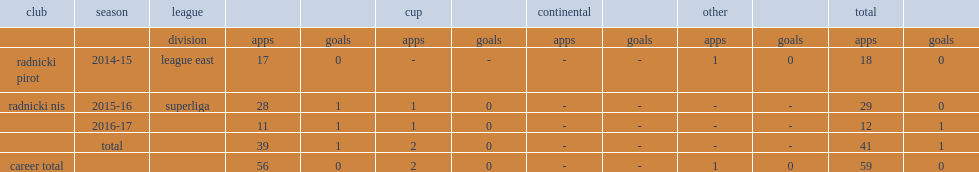How many goals did apostolovic score for radnicki nis in 12 fixture of the 2016-17 superliga season? 1.0. 